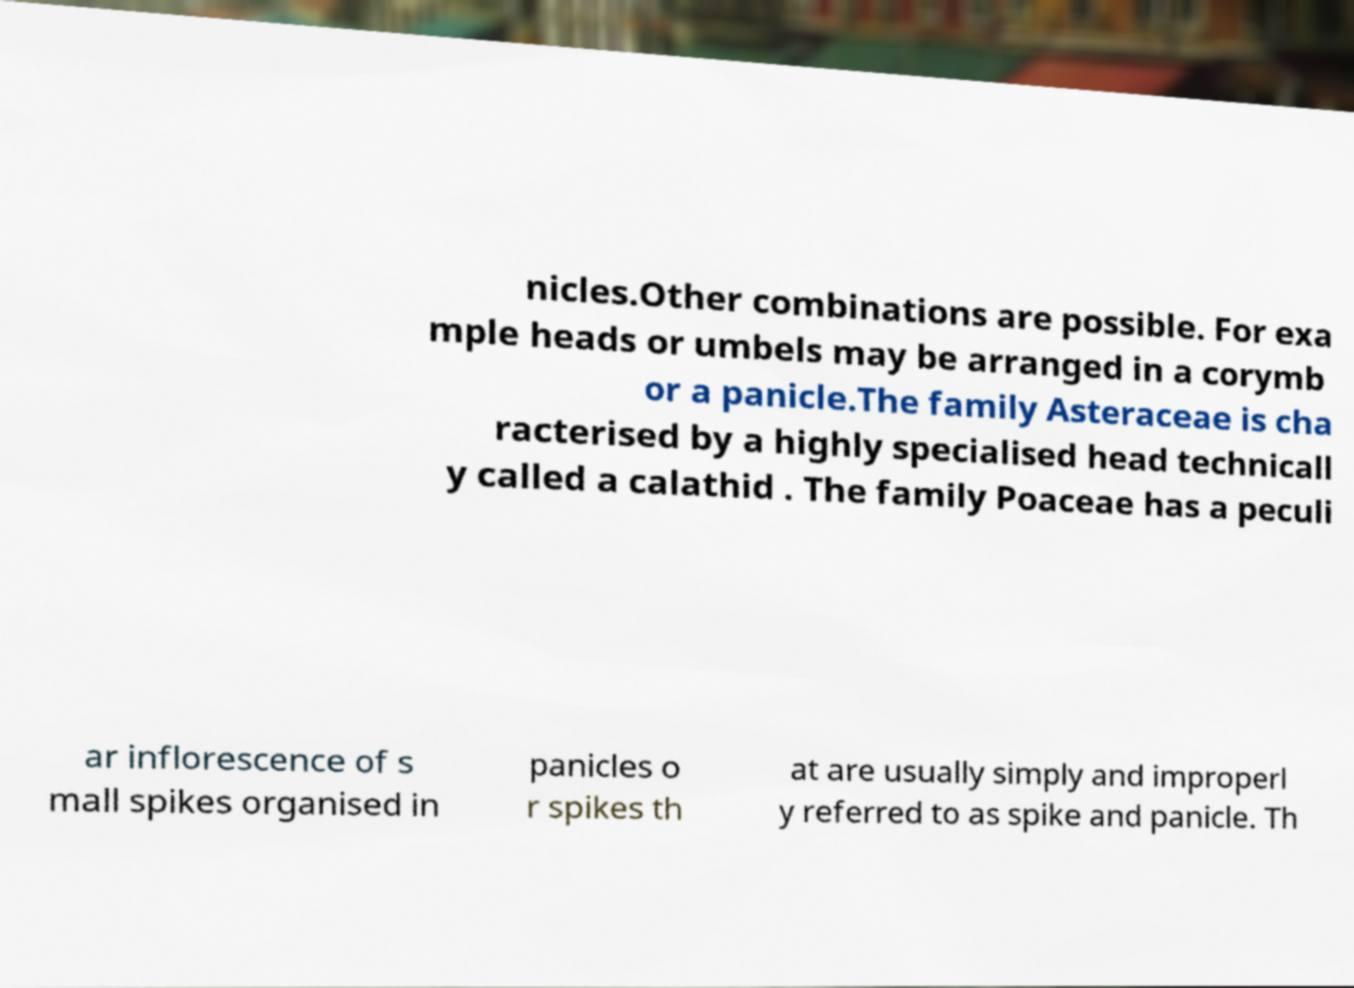I need the written content from this picture converted into text. Can you do that? nicles.Other combinations are possible. For exa mple heads or umbels may be arranged in a corymb or a panicle.The family Asteraceae is cha racterised by a highly specialised head technicall y called a calathid . The family Poaceae has a peculi ar inflorescence of s mall spikes organised in panicles o r spikes th at are usually simply and improperl y referred to as spike and panicle. Th 